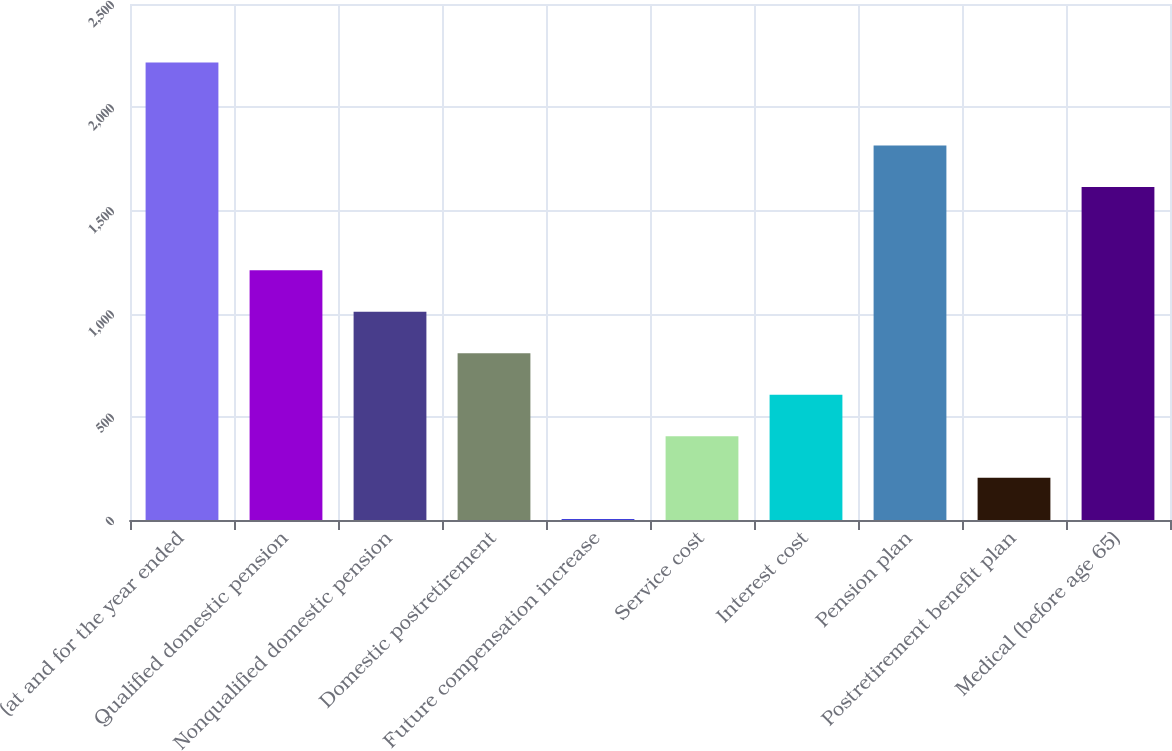<chart> <loc_0><loc_0><loc_500><loc_500><bar_chart><fcel>(at and for the year ended<fcel>Qualified domestic pension<fcel>Nonqualified domestic pension<fcel>Domestic postretirement<fcel>Future compensation increase<fcel>Service cost<fcel>Interest cost<fcel>Pension plan<fcel>Postretirement benefit plan<fcel>Medical (before age 65)<nl><fcel>2216.1<fcel>1210.6<fcel>1009.5<fcel>808.4<fcel>4<fcel>406.2<fcel>607.3<fcel>1813.9<fcel>205.1<fcel>1612.8<nl></chart> 